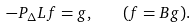<formula> <loc_0><loc_0><loc_500><loc_500>- P _ { \Delta } L f = g , \quad ( f = B g ) .</formula> 